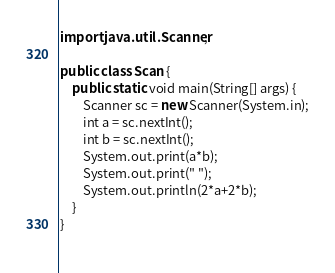Convert code to text. <code><loc_0><loc_0><loc_500><loc_500><_Java_>import java.util.Scanner;
 
public class Scan {
    public static void main(String[] args) {
        Scanner sc = new Scanner(System.in);
        int a = sc.nextInt();
        int b = sc.nextInt();
        System.out.print(a*b);
        System.out.print(" ");
        System.out.println(2*a+2*b);
    }
}
 </code> 